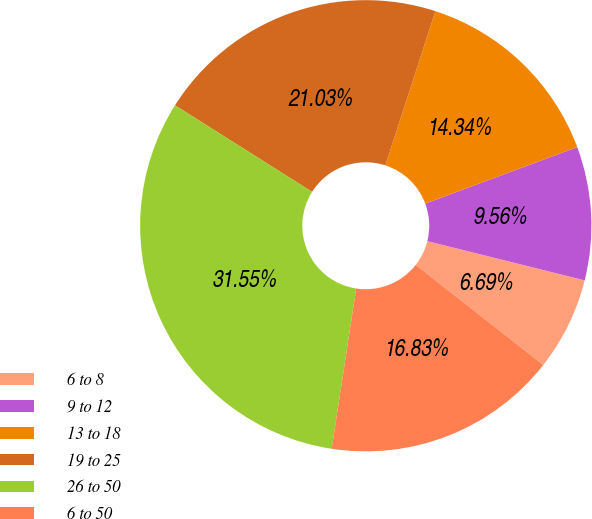<chart> <loc_0><loc_0><loc_500><loc_500><pie_chart><fcel>6 to 8<fcel>9 to 12<fcel>13 to 18<fcel>19 to 25<fcel>26 to 50<fcel>6 to 50<nl><fcel>6.69%<fcel>9.56%<fcel>14.34%<fcel>21.03%<fcel>31.55%<fcel>16.83%<nl></chart> 